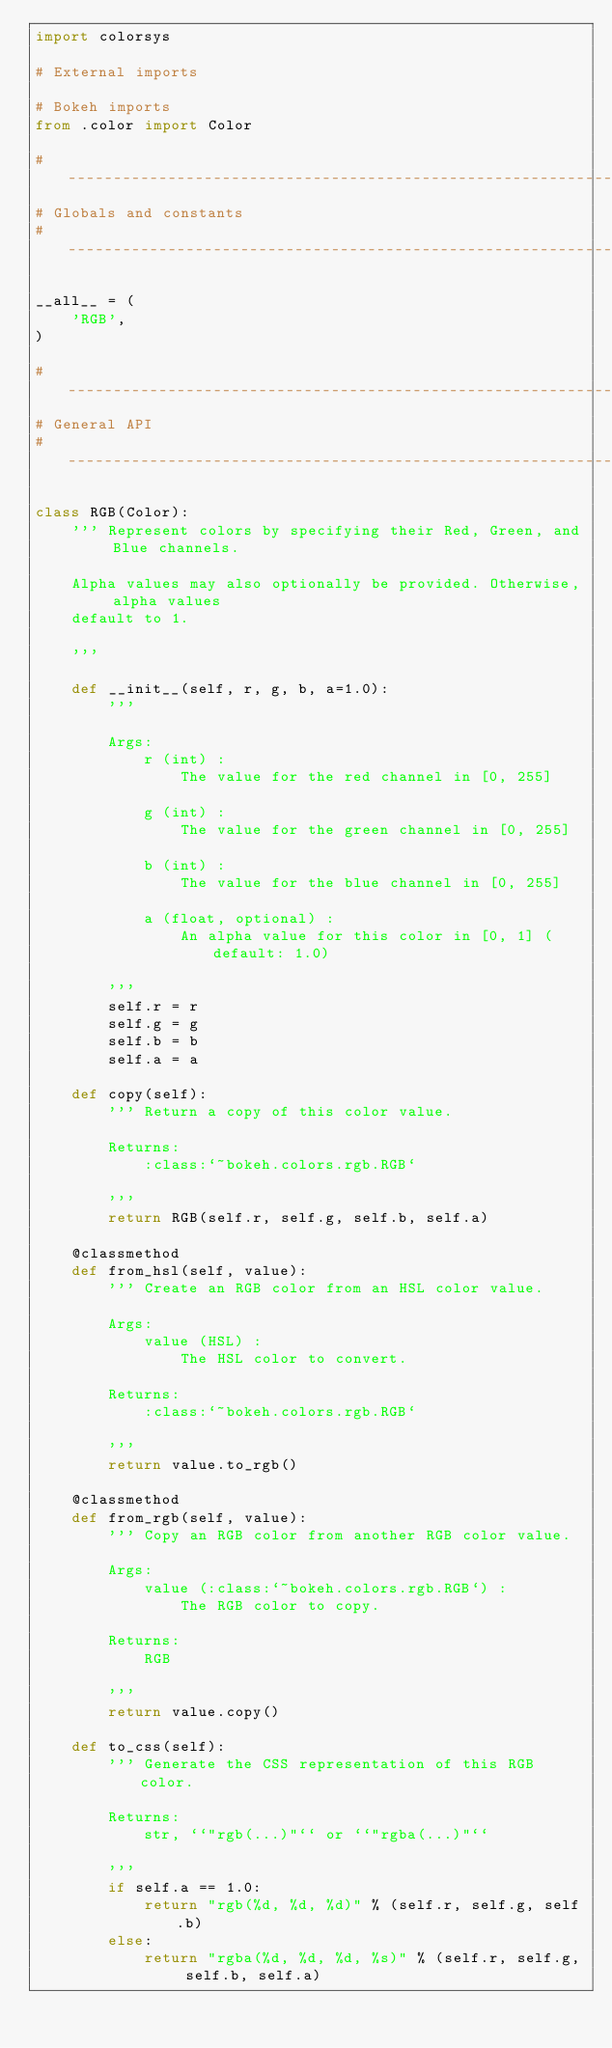<code> <loc_0><loc_0><loc_500><loc_500><_Python_>import colorsys

# External imports

# Bokeh imports
from .color import Color

#-----------------------------------------------------------------------------
# Globals and constants
#-----------------------------------------------------------------------------

__all__ = (
    'RGB',
)

#-----------------------------------------------------------------------------
# General API
#-----------------------------------------------------------------------------

class RGB(Color):
    ''' Represent colors by specifying their Red, Green, and Blue channels.

    Alpha values may also optionally be provided. Otherwise, alpha values
    default to 1.

    '''

    def __init__(self, r, g, b, a=1.0):
        '''

        Args:
            r (int) :
                The value for the red channel in [0, 255]

            g (int) :
                The value for the green channel in [0, 255]

            b (int) :
                The value for the blue channel in [0, 255]

            a (float, optional) :
                An alpha value for this color in [0, 1] (default: 1.0)

        '''
        self.r = r
        self.g = g
        self.b = b
        self.a = a

    def copy(self):
        ''' Return a copy of this color value.

        Returns:
            :class:`~bokeh.colors.rgb.RGB`

        '''
        return RGB(self.r, self.g, self.b, self.a)

    @classmethod
    def from_hsl(self, value):
        ''' Create an RGB color from an HSL color value.

        Args:
            value (HSL) :
                The HSL color to convert.

        Returns:
            :class:`~bokeh.colors.rgb.RGB`

        '''
        return value.to_rgb()

    @classmethod
    def from_rgb(self, value):
        ''' Copy an RGB color from another RGB color value.

        Args:
            value (:class:`~bokeh.colors.rgb.RGB`) :
                The RGB color to copy.

        Returns:
            RGB

        '''
        return value.copy()

    def to_css(self):
        ''' Generate the CSS representation of this RGB color.

        Returns:
            str, ``"rgb(...)"`` or ``"rgba(...)"``

        '''
        if self.a == 1.0:
            return "rgb(%d, %d, %d)" % (self.r, self.g, self.b)
        else:
            return "rgba(%d, %d, %d, %s)" % (self.r, self.g, self.b, self.a)
</code> 